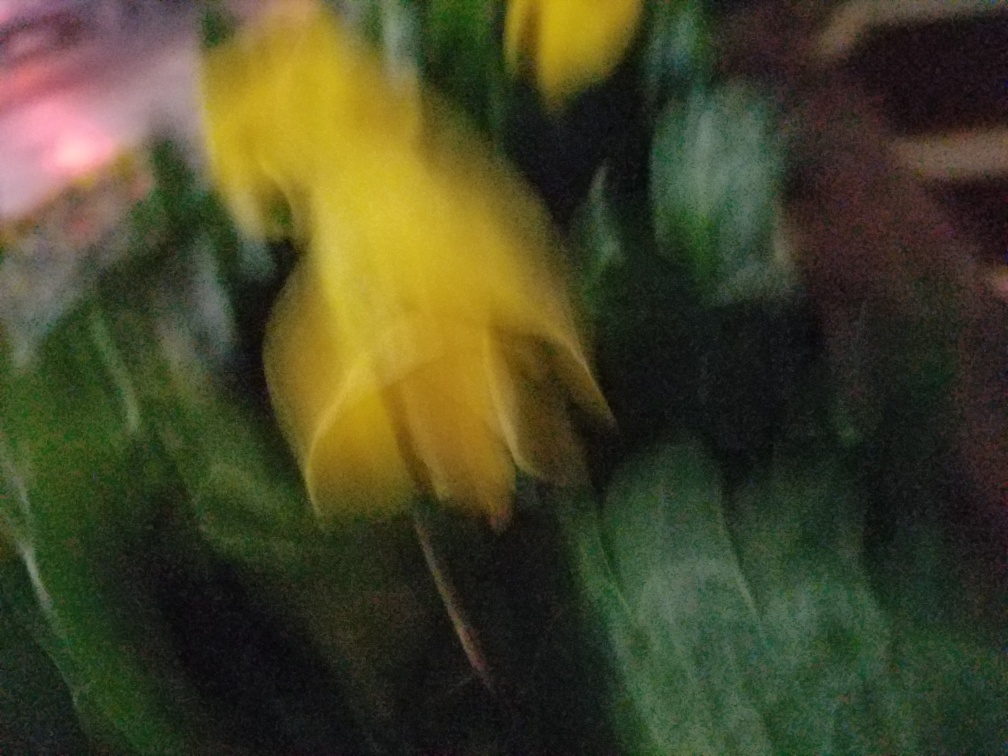Can you determine what object is depicted in this blurred image? It's challenging to make out specific details due to the blur, but it appears to be a flower, possibly yellow in color, amidst green foliage or leaves. 